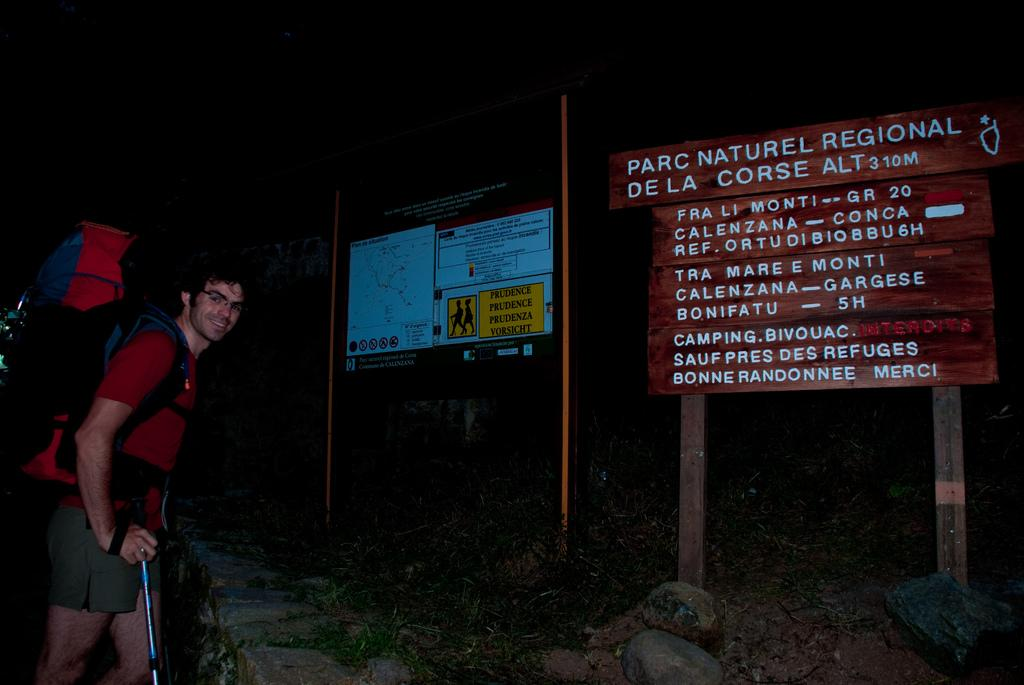What is the main subject of the image? There is a man in the image. What is the man doing in the image? The man is standing in the image. What is the man holding in his hand? The man is holding a stick in his hand. What is the man wearing on his back? The man is wearing a backpack on his back. What can be seen on the boards in the image? There are boards with text in the image. What type of natural elements are present on the ground in the image? There are rocks on the ground in the image. What song is the man singing in the image? There is no indication in the image that the man is singing a song. What type of house can be seen in the background of the image? There is no house present in the image. 